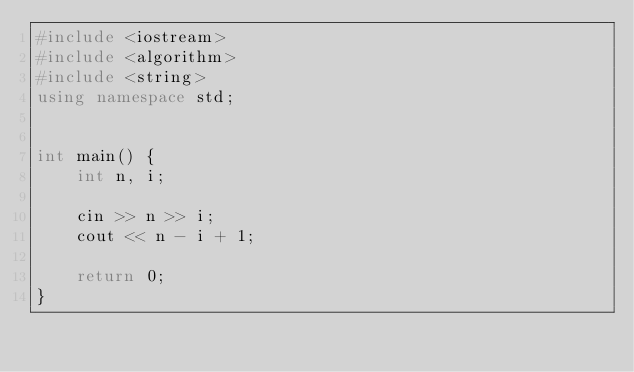<code> <loc_0><loc_0><loc_500><loc_500><_C++_>#include <iostream>
#include <algorithm>
#include <string>
using namespace std;


int main() {
    int n, i;

    cin >> n >> i;
    cout << n - i + 1;

    return 0;
}</code> 